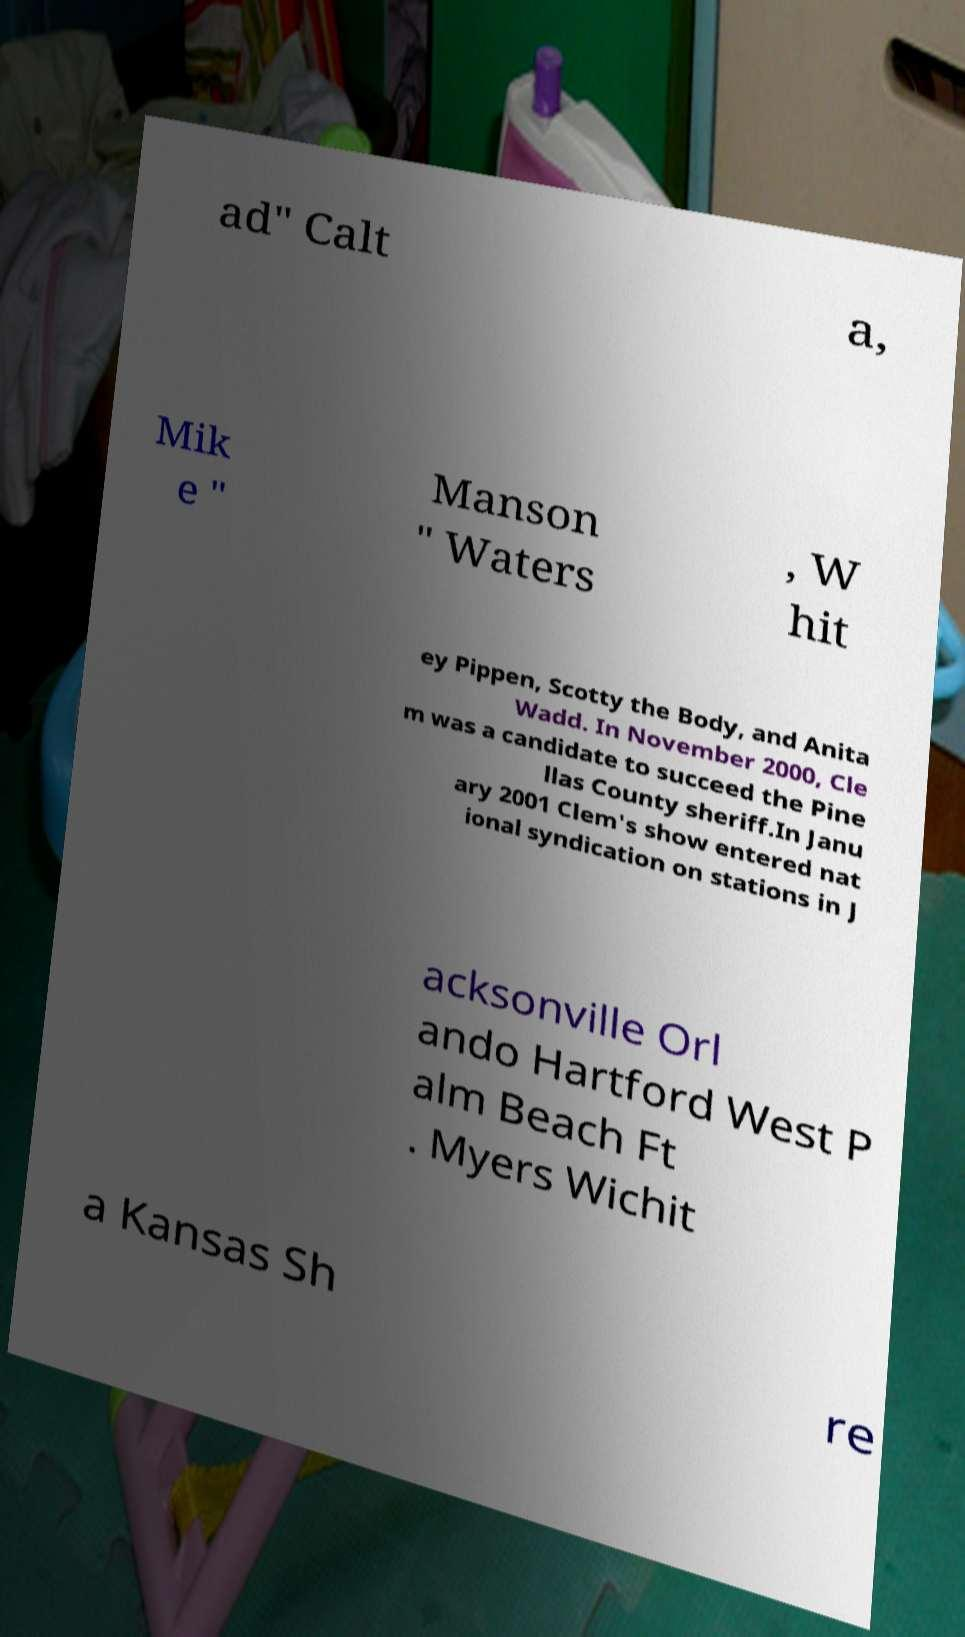I need the written content from this picture converted into text. Can you do that? ad" Calt a, Mik e " Manson " Waters , W hit ey Pippen, Scotty the Body, and Anita Wadd. In November 2000, Cle m was a candidate to succeed the Pine llas County sheriff.In Janu ary 2001 Clem's show entered nat ional syndication on stations in J acksonville Orl ando Hartford West P alm Beach Ft . Myers Wichit a Kansas Sh re 